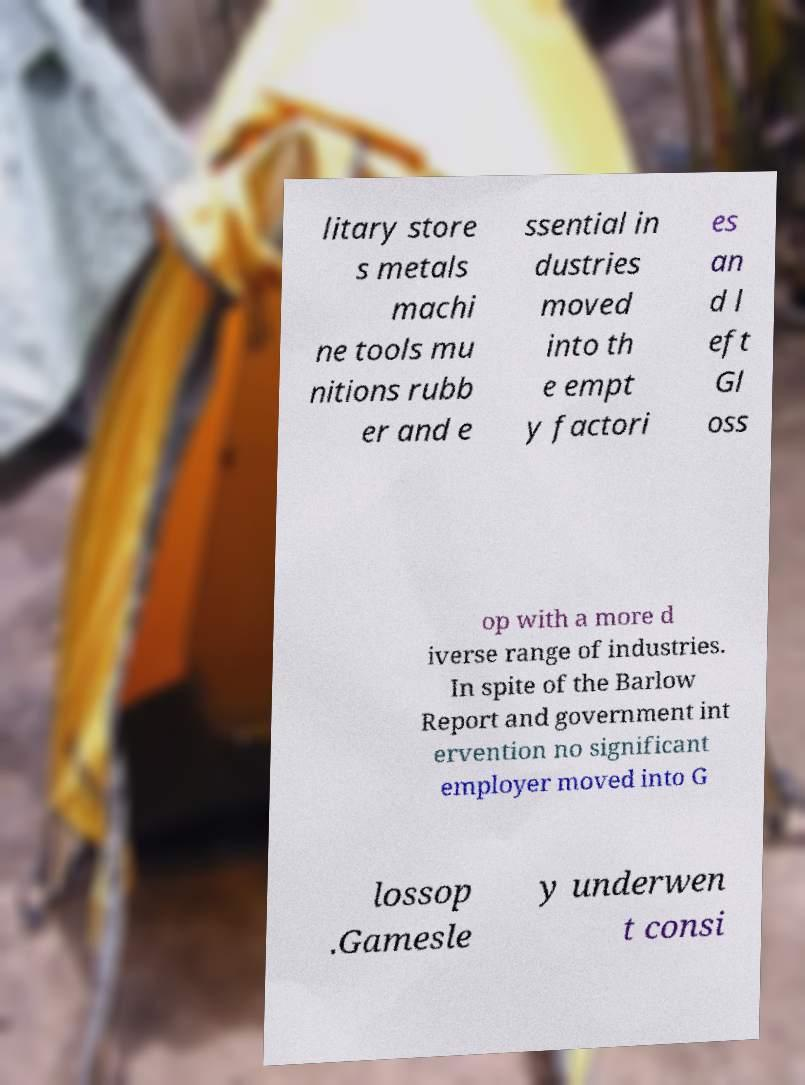Please read and relay the text visible in this image. What does it say? litary store s metals machi ne tools mu nitions rubb er and e ssential in dustries moved into th e empt y factori es an d l eft Gl oss op with a more d iverse range of industries. In spite of the Barlow Report and government int ervention no significant employer moved into G lossop .Gamesle y underwen t consi 